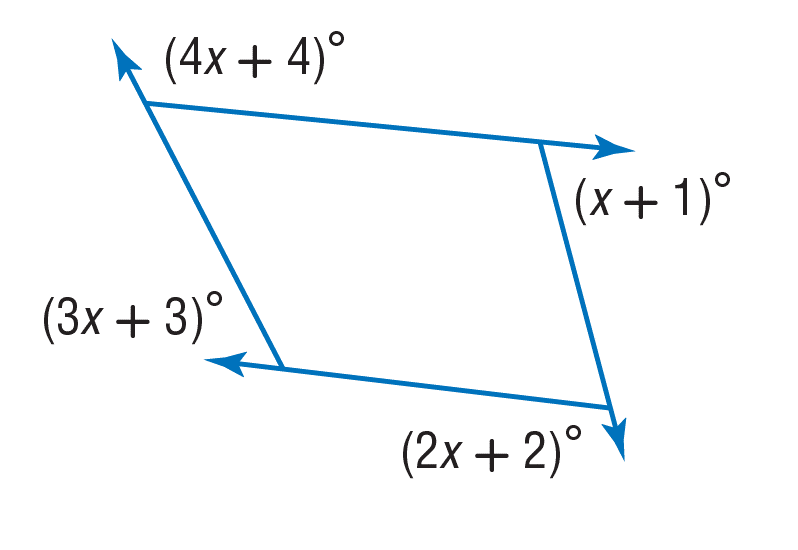Question: Find the value of x.
Choices:
A. 35
B. 36
C. 70
D. 180
Answer with the letter. Answer: A 